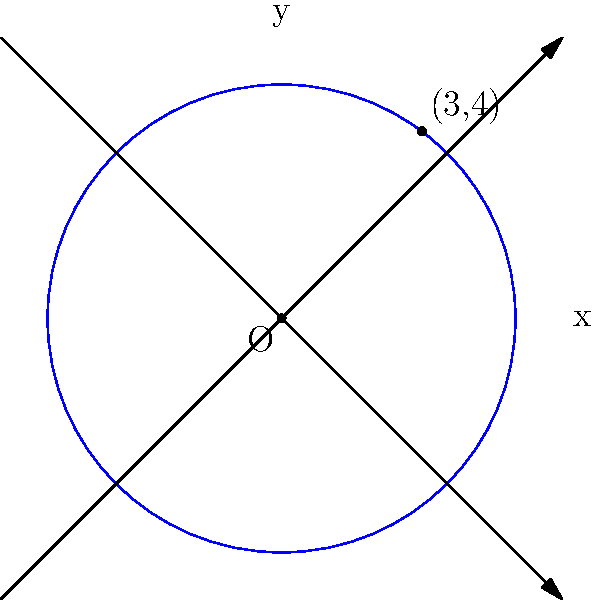A mobile health clinic aims to serve a circular area in an underprivileged community. The clinic's location is represented by the center of the circle at the origin (0,0), and the edge of its coverage area reaches a point (3,4). What is the equation of the circle representing the clinic's coverage area? To find the equation of the circle, we need to follow these steps:

1) The general equation of a circle is $$(x-h)^2 + (y-k)^2 = r^2$$
   where (h,k) is the center and r is the radius.

2) We know the center is at (0,0), so h = 0 and k = 0.

3) To find the radius, we can use the distance formula between (0,0) and (3,4):
   $$r = \sqrt{(3-0)^2 + (4-0)^2} = \sqrt{9 + 16} = \sqrt{25} = 5$$

4) Now we can write the equation:
   $$(x-0)^2 + (y-0)^2 = 5^2$$

5) Simplifying:
   $$x^2 + y^2 = 25$$

This is the equation of the circle representing the clinic's coverage area.
Answer: $x^2 + y^2 = 25$ 